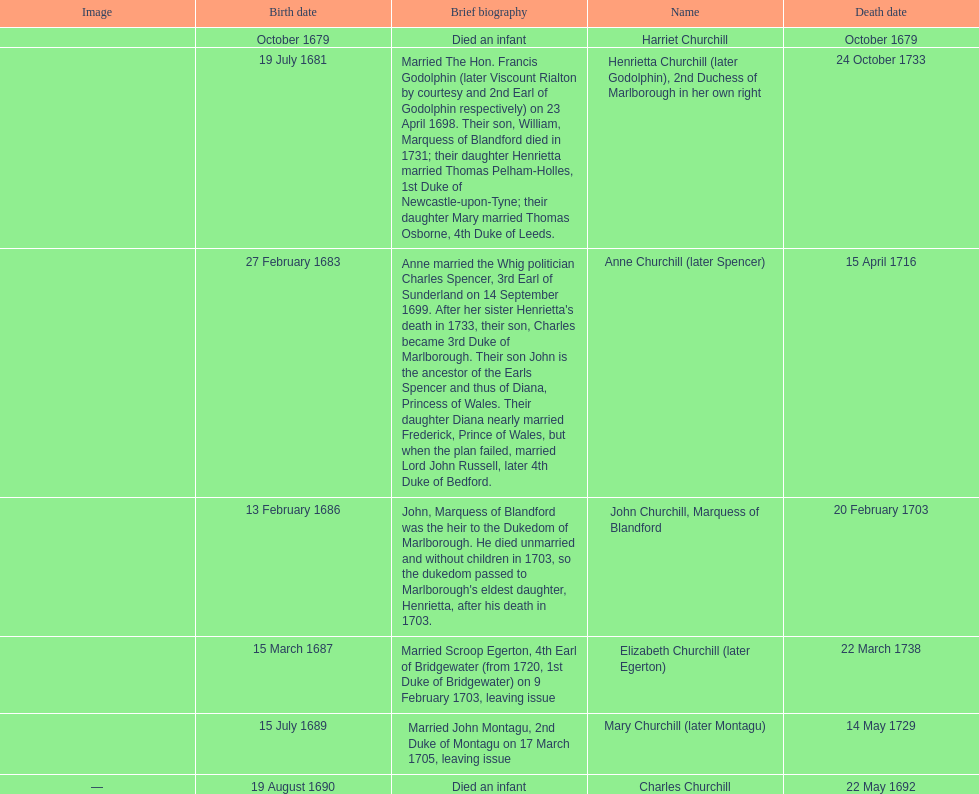Which child was the first to die? Harriet Churchill. Parse the table in full. {'header': ['Image', 'Birth date', 'Brief biography', 'Name', 'Death date'], 'rows': [['', 'October 1679', 'Died an infant', 'Harriet Churchill', 'October 1679'], ['', '19 July 1681', 'Married The Hon. Francis Godolphin (later Viscount Rialton by courtesy and 2nd Earl of Godolphin respectively) on 23 April 1698. Their son, William, Marquess of Blandford died in 1731; their daughter Henrietta married Thomas Pelham-Holles, 1st Duke of Newcastle-upon-Tyne; their daughter Mary married Thomas Osborne, 4th Duke of Leeds.', 'Henrietta Churchill (later Godolphin), 2nd Duchess of Marlborough in her own right', '24 October 1733'], ['', '27 February 1683', "Anne married the Whig politician Charles Spencer, 3rd Earl of Sunderland on 14 September 1699. After her sister Henrietta's death in 1733, their son, Charles became 3rd Duke of Marlborough. Their son John is the ancestor of the Earls Spencer and thus of Diana, Princess of Wales. Their daughter Diana nearly married Frederick, Prince of Wales, but when the plan failed, married Lord John Russell, later 4th Duke of Bedford.", 'Anne Churchill (later Spencer)', '15 April 1716'], ['', '13 February 1686', "John, Marquess of Blandford was the heir to the Dukedom of Marlborough. He died unmarried and without children in 1703, so the dukedom passed to Marlborough's eldest daughter, Henrietta, after his death in 1703.", 'John Churchill, Marquess of Blandford', '20 February 1703'], ['', '15 March 1687', 'Married Scroop Egerton, 4th Earl of Bridgewater (from 1720, 1st Duke of Bridgewater) on 9 February 1703, leaving issue', 'Elizabeth Churchill (later Egerton)', '22 March 1738'], ['', '15 July 1689', 'Married John Montagu, 2nd Duke of Montagu on 17 March 1705, leaving issue', 'Mary Churchill (later Montagu)', '14 May 1729'], ['—', '19 August 1690', 'Died an infant', 'Charles Churchill', '22 May 1692']]} 